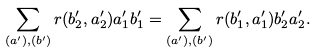Convert formula to latex. <formula><loc_0><loc_0><loc_500><loc_500>\sum _ { ( a ^ { \prime } ) , ( b ^ { \prime } ) } r ( b ^ { \prime } _ { 2 } , a ^ { \prime } _ { 2 } ) a ^ { \prime } _ { 1 } b ^ { \prime } _ { 1 } = \sum _ { ( a ^ { \prime } ) , ( b ^ { \prime } ) } r ( b ^ { \prime } _ { 1 } , a ^ { \prime } _ { 1 } ) b ^ { \prime } _ { 2 } a ^ { \prime } _ { 2 } .</formula> 